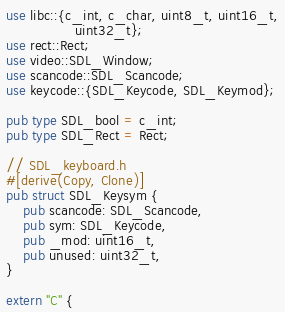Convert code to text. <code><loc_0><loc_0><loc_500><loc_500><_Rust_>use libc::{c_int, c_char, uint8_t, uint16_t,
                uint32_t};
use rect::Rect;
use video::SDL_Window;
use scancode::SDL_Scancode;
use keycode::{SDL_Keycode, SDL_Keymod};

pub type SDL_bool = c_int;
pub type SDL_Rect = Rect;

// SDL_keyboard.h
#[derive(Copy, Clone)]
pub struct SDL_Keysym {
    pub scancode: SDL_Scancode,
    pub sym: SDL_Keycode,
    pub _mod: uint16_t,
    pub unused: uint32_t,
}

extern "C" {</code> 